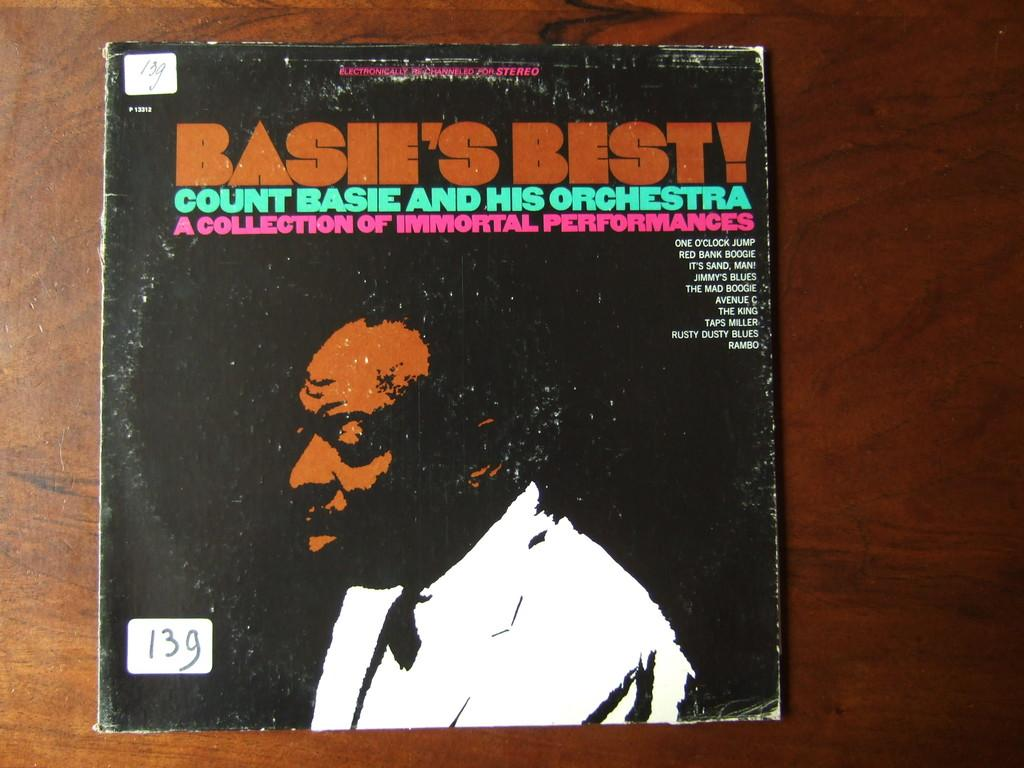<image>
Offer a succinct explanation of the picture presented. Basie's best count basie and his orchestra collection 